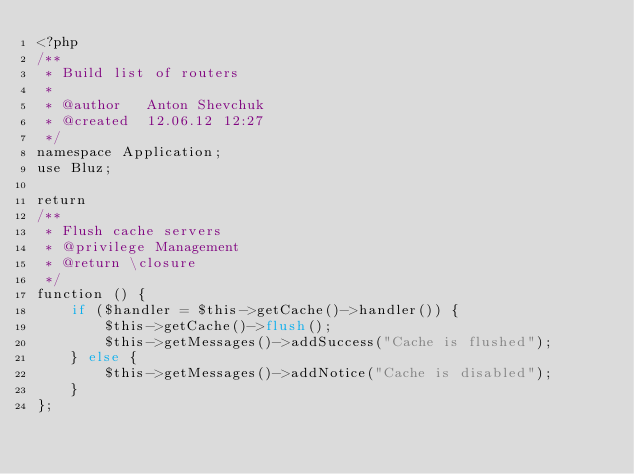<code> <loc_0><loc_0><loc_500><loc_500><_PHP_><?php
/**
 * Build list of routers
 *
 * @author   Anton Shevchuk
 * @created  12.06.12 12:27
 */
namespace Application;
use Bluz;

return
/**
 * Flush cache servers
 * @privilege Management
 * @return \closure
 */
function () {
    if ($handler = $this->getCache()->handler()) {
        $this->getCache()->flush();
        $this->getMessages()->addSuccess("Cache is flushed");
    } else {
        $this->getMessages()->addNotice("Cache is disabled");
    }
};</code> 